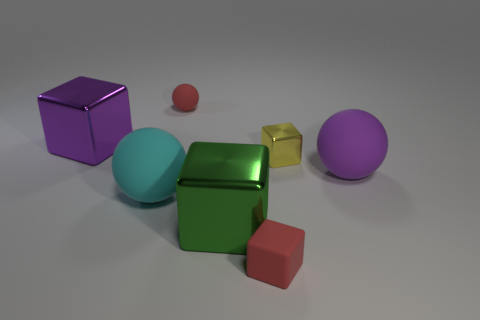Subtract all gray blocks. Subtract all red cylinders. How many blocks are left? 4 Add 1 cylinders. How many objects exist? 8 Subtract all cubes. How many objects are left? 3 Subtract all big purple shiny objects. Subtract all cyan rubber spheres. How many objects are left? 5 Add 6 large metal blocks. How many large metal blocks are left? 8 Add 1 tiny red spheres. How many tiny red spheres exist? 2 Subtract 0 blue blocks. How many objects are left? 7 